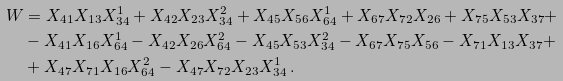<formula> <loc_0><loc_0><loc_500><loc_500>W & = X _ { 4 1 } X _ { 1 3 } X _ { 3 4 } ^ { 1 } + X _ { 4 2 } X _ { 2 3 } X _ { 3 4 } ^ { 2 } + X _ { 4 5 } X _ { 5 6 } X _ { 6 4 } ^ { 1 } + X _ { 6 7 } X _ { 7 2 } X _ { 2 6 } + X _ { 7 5 } X _ { 5 3 } X _ { 3 7 } + \\ & - X _ { 4 1 } X _ { 1 6 } X _ { 6 4 } ^ { 1 } - X _ { 4 2 } X _ { 2 6 } X _ { 6 4 } ^ { 2 } - X _ { 4 5 } X _ { 5 3 } X _ { 3 4 } ^ { 2 } - X _ { 6 7 } X _ { 7 5 } X _ { 5 6 } - X _ { 7 1 } X _ { 1 3 } X _ { 3 7 } + \\ & + X _ { 4 7 } X _ { 7 1 } X _ { 1 6 } X _ { 6 4 } ^ { 2 } - X _ { 4 7 } X _ { 7 2 } X _ { 2 3 } X _ { 3 4 } ^ { 1 } \, .</formula> 